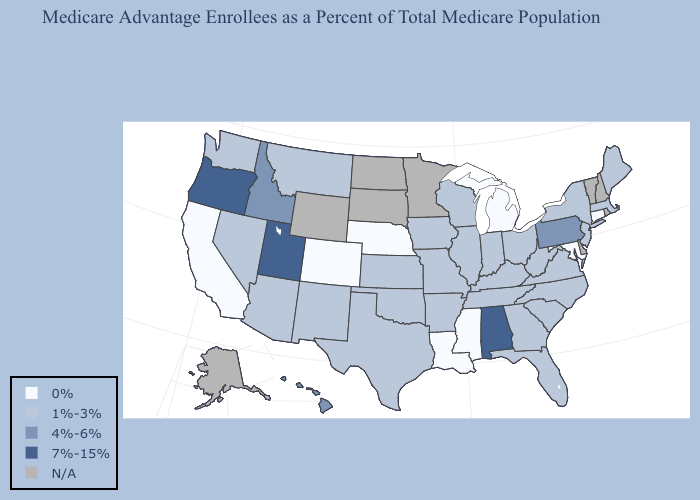Name the states that have a value in the range 0%?
Short answer required. California, Colorado, Connecticut, Louisiana, Maryland, Michigan, Mississippi, Nebraska. Does New Jersey have the highest value in the Northeast?
Quick response, please. No. Which states have the lowest value in the Northeast?
Be succinct. Connecticut. Does the map have missing data?
Give a very brief answer. Yes. What is the value of Connecticut?
Short answer required. 0%. What is the value of West Virginia?
Write a very short answer. 1%-3%. Which states have the highest value in the USA?
Give a very brief answer. Alabama, Oregon, Utah. What is the value of Colorado?
Give a very brief answer. 0%. Name the states that have a value in the range 4%-6%?
Short answer required. Hawaii, Idaho, Pennsylvania. What is the value of New Jersey?
Short answer required. 1%-3%. Which states have the highest value in the USA?
Short answer required. Alabama, Oregon, Utah. Which states have the lowest value in the MidWest?
Answer briefly. Michigan, Nebraska. How many symbols are there in the legend?
Keep it brief. 5. What is the lowest value in the MidWest?
Be succinct. 0%. 